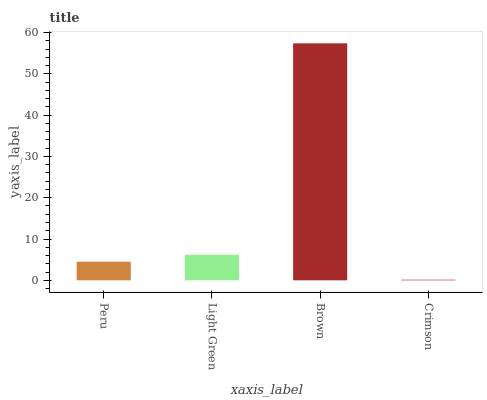Is Crimson the minimum?
Answer yes or no. Yes. Is Brown the maximum?
Answer yes or no. Yes. Is Light Green the minimum?
Answer yes or no. No. Is Light Green the maximum?
Answer yes or no. No. Is Light Green greater than Peru?
Answer yes or no. Yes. Is Peru less than Light Green?
Answer yes or no. Yes. Is Peru greater than Light Green?
Answer yes or no. No. Is Light Green less than Peru?
Answer yes or no. No. Is Light Green the high median?
Answer yes or no. Yes. Is Peru the low median?
Answer yes or no. Yes. Is Brown the high median?
Answer yes or no. No. Is Brown the low median?
Answer yes or no. No. 